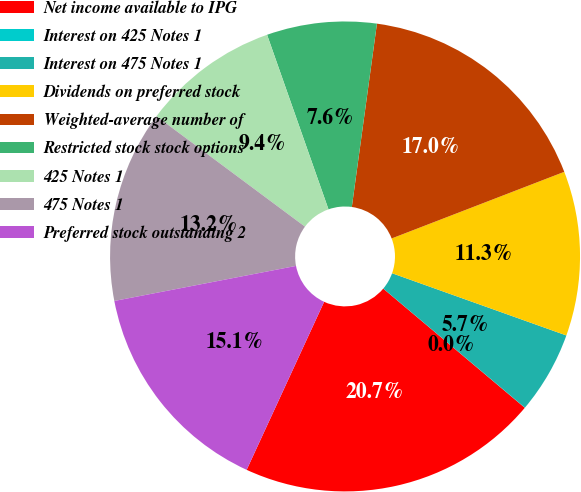<chart> <loc_0><loc_0><loc_500><loc_500><pie_chart><fcel>Net income available to IPG<fcel>Interest on 425 Notes 1<fcel>Interest on 475 Notes 1<fcel>Dividends on preferred stock<fcel>Weighted-average number of<fcel>Restricted stock stock options<fcel>425 Notes 1<fcel>475 Notes 1<fcel>Preferred stock outstanding 2<nl><fcel>20.74%<fcel>0.01%<fcel>5.67%<fcel>11.32%<fcel>16.97%<fcel>7.55%<fcel>9.44%<fcel>13.21%<fcel>15.09%<nl></chart> 